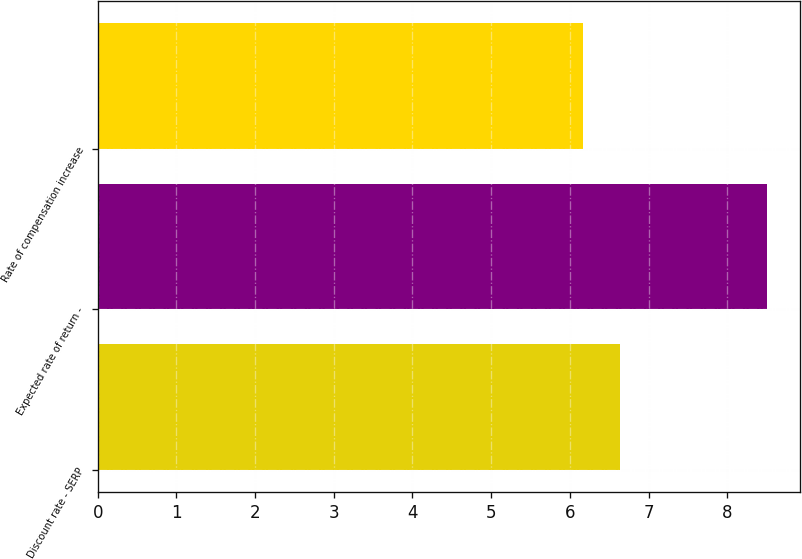Convert chart. <chart><loc_0><loc_0><loc_500><loc_500><bar_chart><fcel>Discount rate - SERP<fcel>Expected rate of return -<fcel>Rate of compensation increase<nl><fcel>6.64<fcel>8.5<fcel>6.17<nl></chart> 